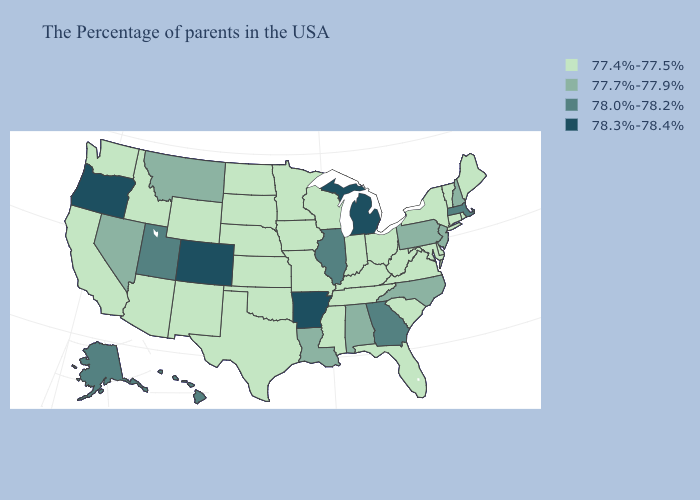Which states have the lowest value in the Northeast?
Be succinct. Maine, Rhode Island, Vermont, Connecticut, New York. Name the states that have a value in the range 78.0%-78.2%?
Be succinct. Massachusetts, Georgia, Illinois, Utah, Alaska, Hawaii. Name the states that have a value in the range 78.3%-78.4%?
Short answer required. Michigan, Arkansas, Colorado, Oregon. What is the value of New Jersey?
Concise answer only. 77.7%-77.9%. Among the states that border Kentucky , which have the highest value?
Give a very brief answer. Illinois. Which states have the lowest value in the MidWest?
Answer briefly. Ohio, Indiana, Wisconsin, Missouri, Minnesota, Iowa, Kansas, Nebraska, South Dakota, North Dakota. Name the states that have a value in the range 77.4%-77.5%?
Write a very short answer. Maine, Rhode Island, Vermont, Connecticut, New York, Delaware, Maryland, Virginia, South Carolina, West Virginia, Ohio, Florida, Kentucky, Indiana, Tennessee, Wisconsin, Mississippi, Missouri, Minnesota, Iowa, Kansas, Nebraska, Oklahoma, Texas, South Dakota, North Dakota, Wyoming, New Mexico, Arizona, Idaho, California, Washington. What is the value of Nevada?
Write a very short answer. 77.7%-77.9%. What is the value of Rhode Island?
Be succinct. 77.4%-77.5%. Name the states that have a value in the range 77.7%-77.9%?
Be succinct. New Hampshire, New Jersey, Pennsylvania, North Carolina, Alabama, Louisiana, Montana, Nevada. Name the states that have a value in the range 77.4%-77.5%?
Keep it brief. Maine, Rhode Island, Vermont, Connecticut, New York, Delaware, Maryland, Virginia, South Carolina, West Virginia, Ohio, Florida, Kentucky, Indiana, Tennessee, Wisconsin, Mississippi, Missouri, Minnesota, Iowa, Kansas, Nebraska, Oklahoma, Texas, South Dakota, North Dakota, Wyoming, New Mexico, Arizona, Idaho, California, Washington. Name the states that have a value in the range 77.7%-77.9%?
Quick response, please. New Hampshire, New Jersey, Pennsylvania, North Carolina, Alabama, Louisiana, Montana, Nevada. Among the states that border Arkansas , which have the highest value?
Concise answer only. Louisiana. Among the states that border Arizona , does New Mexico have the lowest value?
Be succinct. Yes. What is the highest value in states that border Delaware?
Keep it brief. 77.7%-77.9%. 